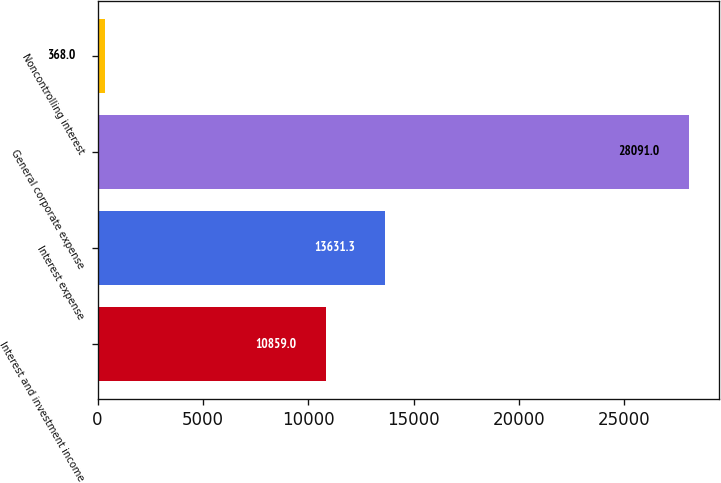Convert chart. <chart><loc_0><loc_0><loc_500><loc_500><bar_chart><fcel>Interest and investment income<fcel>Interest expense<fcel>General corporate expense<fcel>Noncontrolling interest<nl><fcel>10859<fcel>13631.3<fcel>28091<fcel>368<nl></chart> 